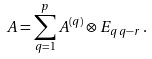Convert formula to latex. <formula><loc_0><loc_0><loc_500><loc_500>A = \sum _ { q = 1 } ^ { p } A ^ { ( q ) } \otimes E _ { q \, q - r } \, .</formula> 